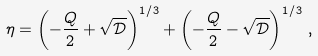Convert formula to latex. <formula><loc_0><loc_0><loc_500><loc_500>\eta = \left ( - \frac { Q } { 2 } + \sqrt { \mathcal { D } } \right ) ^ { 1 / 3 } + \left ( - \frac { Q } { 2 } - \sqrt { \mathcal { D } } \right ) ^ { 1 / 3 } \, ,</formula> 